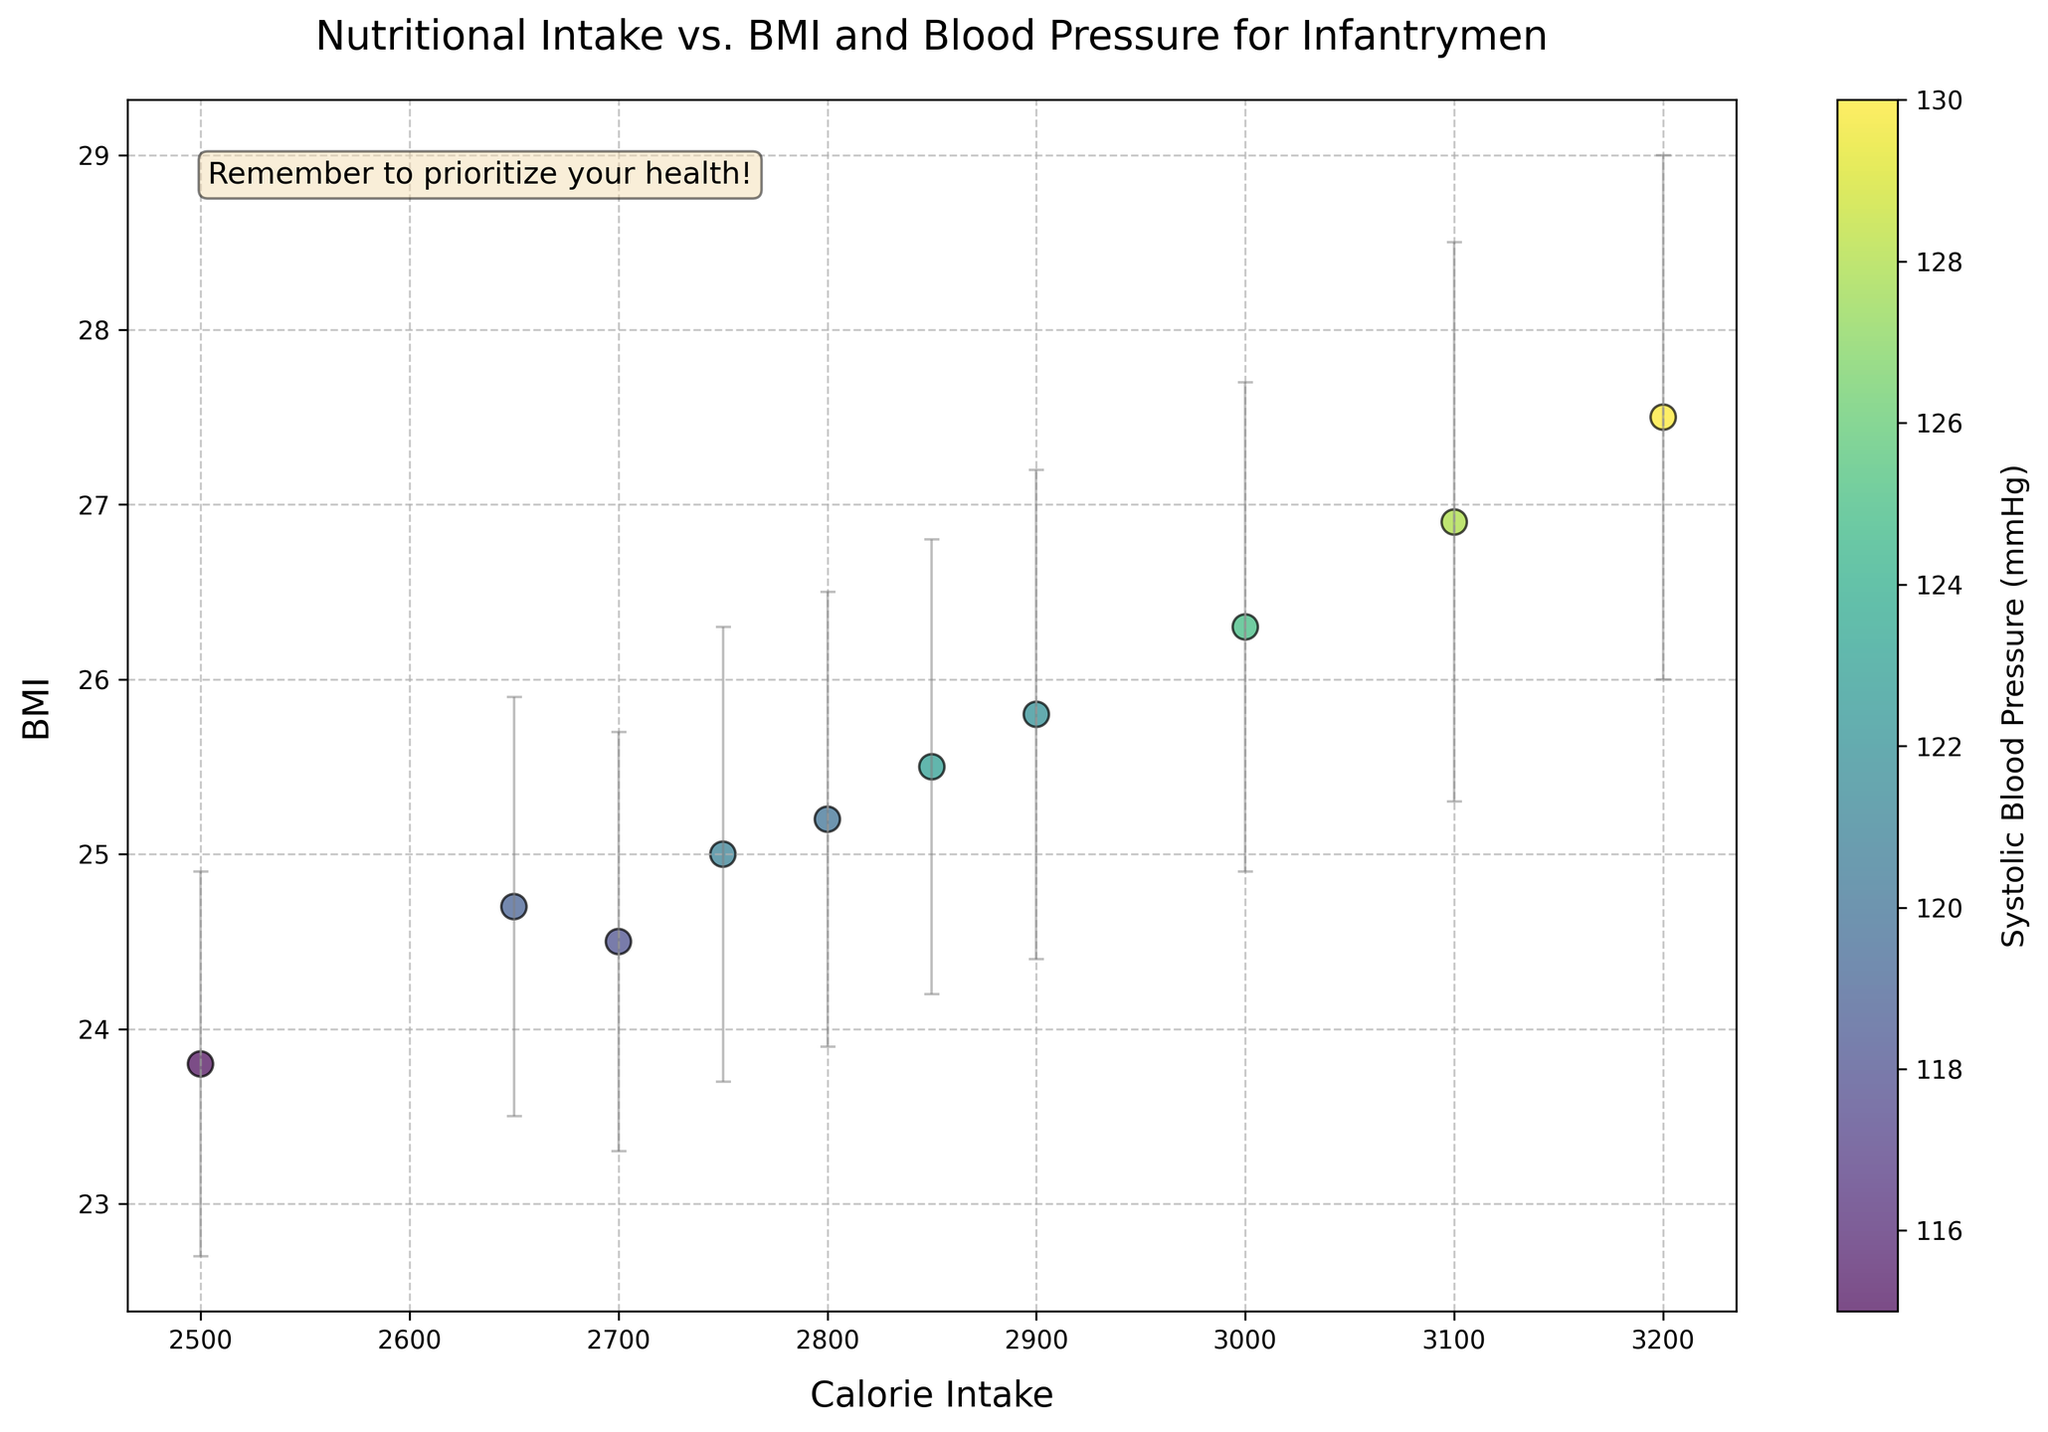What is the title of the plot? The title of the plot is usually displayed prominently at the top of the figure. In this case, the title is "Nutritional Intake vs. BMI and Blood Pressure for Infantrymen".
Answer: Nutritional Intake vs. BMI and Blood Pressure for Infantrymen Which axis represents Calorie Intake? The figure shows labeled axes, and the x-axis is labeled "Calorie Intake", indicating it represents Calorie Intake.
Answer: x-axis How many infantrymen's data points are plotted? There are individual data points marked on the scatter plot. Counting these points gives the total number of personnel surveyed.
Answer: 10 What does the color of the data points represent? The color of the data points corresponds to the value of Systolic Blood Pressure, as indicated by the color bar to the right of the plot.
Answer: Systolic Blood Pressure Which data point has the highest Calorie Intake and what is its corresponding BMI? By looking at the scatter plot, identify the data point at the farthest right on the x-axis, which corresponds to the highest Calorie Intake. The BMI value of this point is read from the y-axis.
Answer: Paul Adams has a BMI of 27.5 What is the average BMI of all the data points? To calculate the average BMI, sum all the BMI values and divide by the number of points. Sum = 25.2 + 27.5 + 23.8 + 26.3 + 24.5 + 25.8 + 26.9 + 24.7 + 25.0 + 25.5 = 255.2. Then, divide by 10.
Answer: 25.52 Which point has the lowest BMI variance and what are the corresponding Calorie Intake and BMI values? By examining the plot, find the point where the error bar (BMI variance) is shortest. Note the corresponding x-axis (Calorie Intake) and y-axis (BMI) values.
Answer: David Johnson, with Calorie Intake of 2500 and BMI of 23.8 What is the range of Calories Intake from the smallest to the largest data point? Find the smallest and largest values on the x-axis by locating the points furthest to the left and right, respectively. Their range can be calculated as the difference between the largest and smallest.
Answer: 2500 to 3200 Which infantryman has the closest BMI to 25? Identify the data point nearest to BMI 25 on the y-axis and note the corresponding data point's name.
Answer: Charles Hernandez 